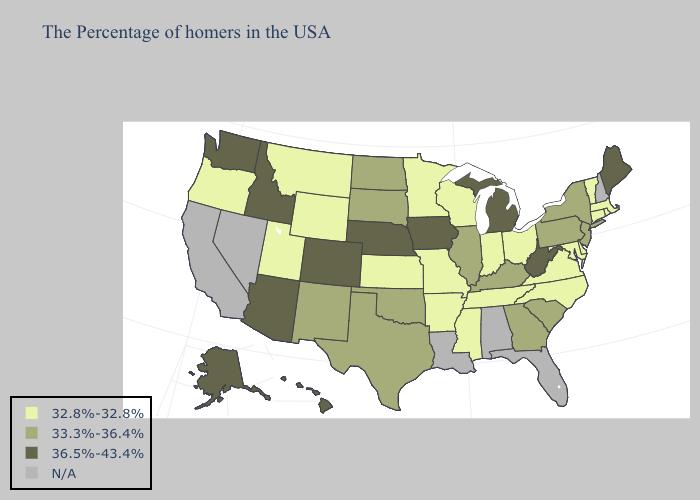What is the lowest value in states that border Indiana?
Give a very brief answer. 32.8%-32.8%. Name the states that have a value in the range 36.5%-43.4%?
Write a very short answer. Maine, West Virginia, Michigan, Iowa, Nebraska, Colorado, Arizona, Idaho, Washington, Alaska, Hawaii. Does South Carolina have the lowest value in the South?
Be succinct. No. Name the states that have a value in the range 36.5%-43.4%?
Answer briefly. Maine, West Virginia, Michigan, Iowa, Nebraska, Colorado, Arizona, Idaho, Washington, Alaska, Hawaii. Among the states that border North Dakota , does Minnesota have the highest value?
Be succinct. No. What is the lowest value in the USA?
Give a very brief answer. 32.8%-32.8%. What is the value of New Jersey?
Be succinct. 33.3%-36.4%. Name the states that have a value in the range N/A?
Concise answer only. New Hampshire, Florida, Alabama, Louisiana, Nevada, California. Which states hav the highest value in the MidWest?
Be succinct. Michigan, Iowa, Nebraska. What is the value of Tennessee?
Write a very short answer. 32.8%-32.8%. What is the highest value in the USA?
Answer briefly. 36.5%-43.4%. What is the value of Iowa?
Give a very brief answer. 36.5%-43.4%. Does South Carolina have the lowest value in the USA?
Keep it brief. No. What is the lowest value in the MidWest?
Short answer required. 32.8%-32.8%. What is the value of Nevada?
Concise answer only. N/A. 